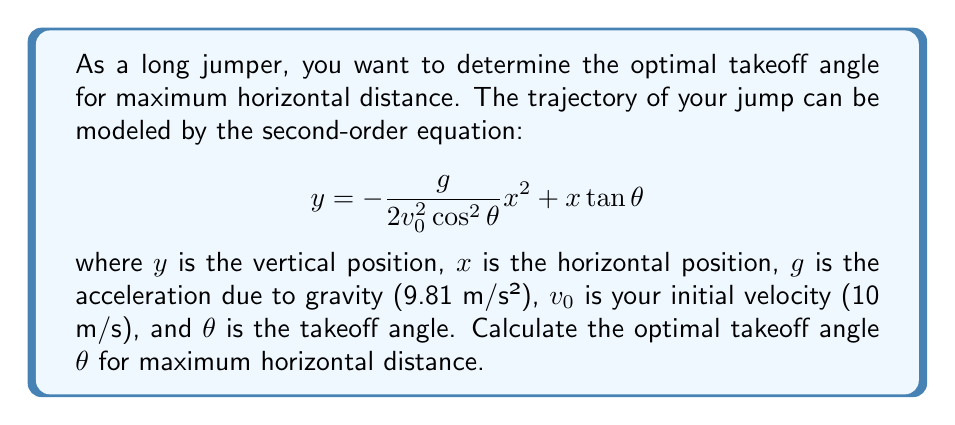Give your solution to this math problem. To find the optimal takeoff angle, we need to maximize the horizontal distance. The jump ends when $y = 0$, so we can solve the equation:

$$0 = -\frac{g}{2v_0^2\cos^2\theta}x^2 + x\tan\theta$$

Rearranging:

$$x = \frac{2v_0^2\cos^2\theta\tan\theta}{g}$$

To maximize $x$, we need to maximize $\cos^2\theta\tan\theta$. Let $u = \cos\theta$:

$$\cos^2\theta\tan\theta = u^2\frac{\sin\theta}{\cos\theta} = u^2\frac{\sqrt{1-u^2}}{u} = u\sqrt{1-u^2}$$

To find the maximum, we differentiate and set to zero:

$$\frac{d}{du}(u\sqrt{1-u^2}) = \sqrt{1-u^2} - \frac{u^2}{\sqrt{1-u^2}} = 0$$

Solving this equation:

$$1-u^2 = u^2$$
$$1 = 2u^2$$
$$u = \frac{1}{\sqrt{2}}$$

Since $u = \cos\theta$, we have:

$$\cos\theta = \frac{1}{\sqrt{2}}$$

Therefore:

$$\theta = \arccos(\frac{1}{\sqrt{2}}) = 45°$$
Answer: The optimal takeoff angle for maximum horizontal distance in a long jump is 45°. 